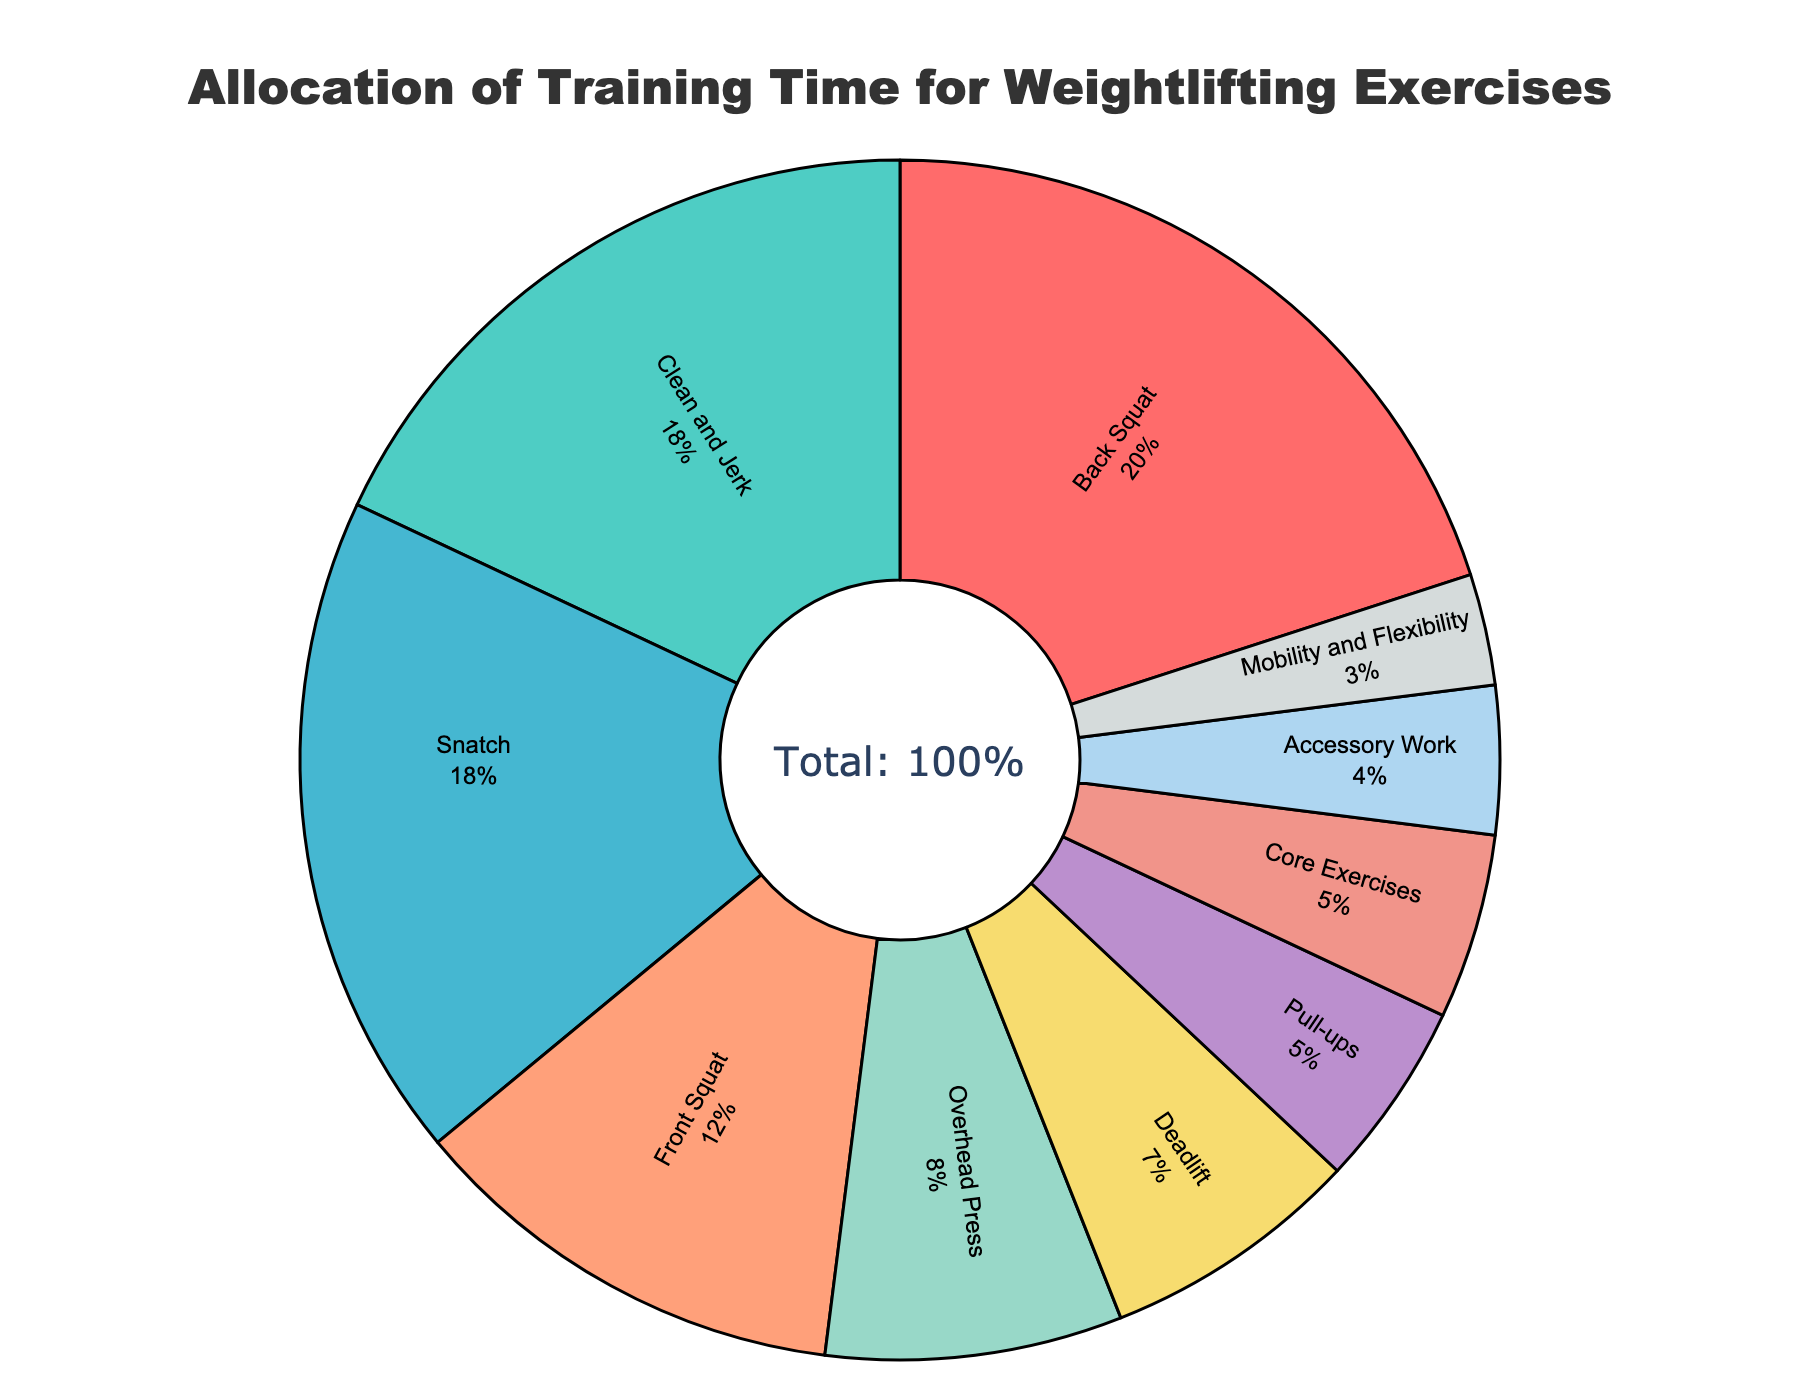What's the most time-consuming exercise in the program? The largest percentage slice in the pie chart represents the most time-consuming exercise. In this case, the Back Squat has the highest allocation at 20%.
Answer: Back Squat How much more training time is allocated to Clean and Jerk compared to Deadlift? Observe the percentages for Clean and Jerk (18%) and Deadlift (7%). Subtract the percentage for Deadlift from Clean and Jerk: 18% - 7% = 11%.
Answer: 11% Are Snatch and Clean and Jerk allocated the same amount of training time? Check the percentages for Snatch and Clean and Jerk. Both are allocated 18%. Therefore, they are equal.
Answer: Yes What is the total percentage of training time allocated to squats (Back Squat and Front Squat)? Add the percentages of Back Squat (20%) and Front Squat (12%): 20% + 12% = 32%.
Answer: 32% Which exercise has the smallest allocation of training time, and what is its percentage? Find the smallest percentage slice in the pie chart, which is Mobility and Flexibility at 3%.
Answer: Mobility and Flexibility, 3% How does the time allocated to Core Exercises compare to Pull-ups? Check the percentages for Core Exercises (5%) and Pull-ups (5%). They both receive the same allocation.
Answer: Equal What is the combined training time for Overhead Press and Deadlift? Add the percentages of Overhead Press (8%) and Deadlift (7%): 8% + 7% = 15%.
Answer: 15% How much more time is allotted to the bench press exercises (Overhead Press) than accessory work? Observe the percentages for Overhead Press (8%) and Accessory Work (4%). Subtract Accessory Work from Overhead Press: 8% - 4% = 4%.
Answer: 4% What are three exercises allocated the bulk of the training time, and what are their combined percentages? The three exercises with the highest percentages are Back Squat (20%), Clean and Jerk (18%), and Snatch (18%). Add their percentages: 20% + 18% + 18% = 56%.
Answer: Back Squat, Clean and Jerk, Snatch; 56% Which exercise is represented by the red color in the pie chart? The red color in the pie chart represents the Back Squat, which has the largest slice.
Answer: Back Squat 